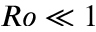<formula> <loc_0><loc_0><loc_500><loc_500>R o \ll 1</formula> 